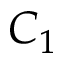<formula> <loc_0><loc_0><loc_500><loc_500>C _ { 1 }</formula> 